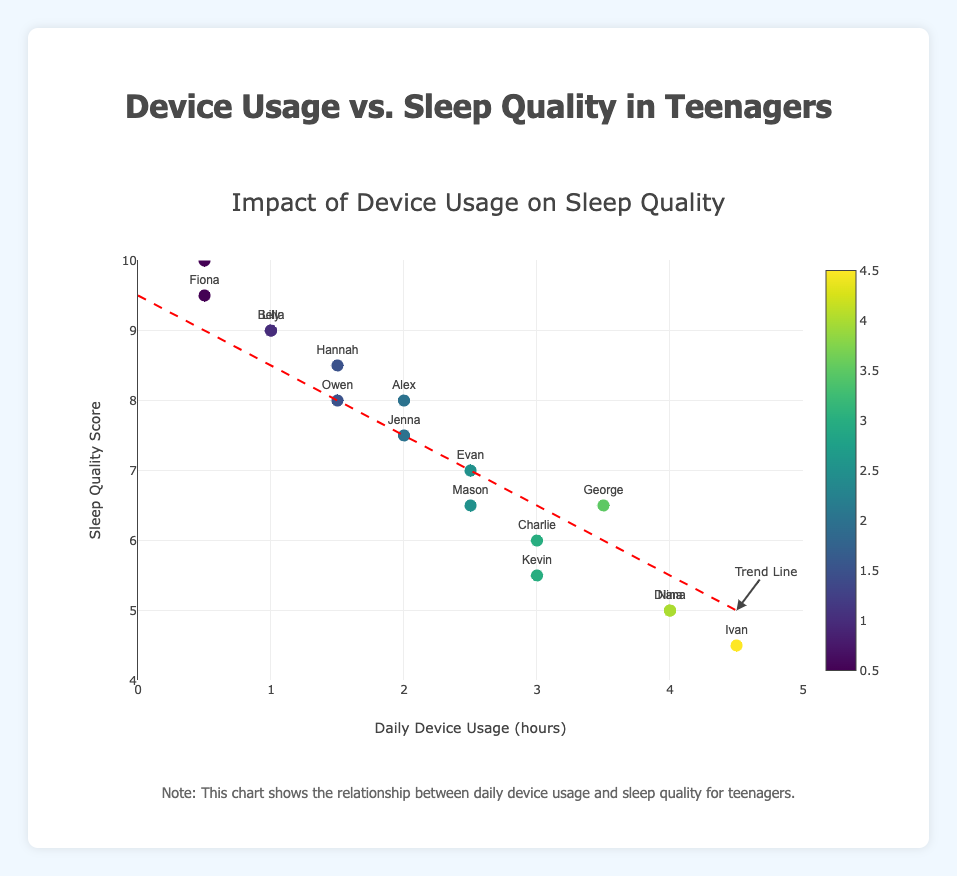What is the title of the plot? The title of the plot is written at the top and reads "Impact of Device Usage on Sleep Quality".
Answer: Impact of Device Usage on Sleep Quality What information does the x-axis represent? The x-axis represents daily device usage in hours.
Answer: Daily Device Usage (hours) How many teenagers had a Sleep Quality Score greater than 9? From the plot, we can see that two teenagers had Sleep Quality Scores greater than 9. These teenagers are Bella and Paula.
Answer: 2 Who had the highest sleep quality score, and what was their device usage? Paula had the highest sleep quality score of 10, and her daily device usage was 0.5 hours.
Answer: Paula, 0.5 hours Which teenager had the lowest sleep quality score, and what was their device usage? Ivan had the lowest sleep quality score of 4.5, and his daily device usage was 4.5 hours.
Answer: Ivan, 4.5 hours Is there a visible trend between device usage hours and sleep quality score? The trend line in the plot shows a negative correlation between device usage hours and sleep quality score, meaning as device usage increases, sleep quality tends to decrease.
Answer: Negative correlation What is the sleep quality score corresponding to 3 hours of device usage per day, according to the trend line? The trend line's approximate equation needs to be considered. For 3 hours of device usage per day, the sleep quality score is around 6 based on the trend line positioning.
Answer: 6 How many teenagers used devices for more than 3 hours per day? From the plot, we observe that four teenagers have daily device usage greater than 3 hours. These teenagers are Diana, George, Ivan, and Nina.
Answer: 4 Which teenager used devices for 2 hours per day, and what are their sleep quality scores? Alex and Jenna both used devices for 2 hours per day. Alex's sleep quality score is 8, and Jenna's score is 7.5.
Answer: Alex: 8, Jenna: 7.5 